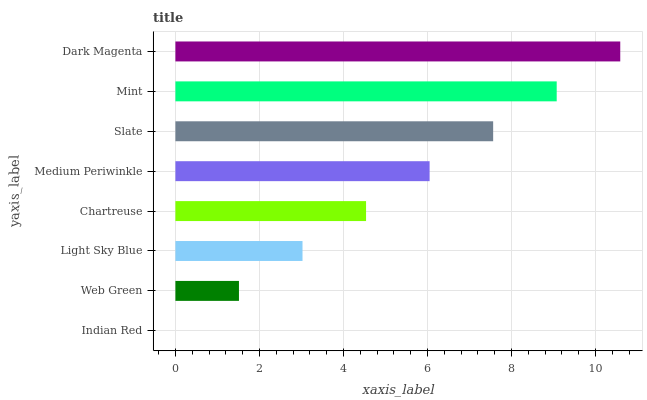Is Indian Red the minimum?
Answer yes or no. Yes. Is Dark Magenta the maximum?
Answer yes or no. Yes. Is Web Green the minimum?
Answer yes or no. No. Is Web Green the maximum?
Answer yes or no. No. Is Web Green greater than Indian Red?
Answer yes or no. Yes. Is Indian Red less than Web Green?
Answer yes or no. Yes. Is Indian Red greater than Web Green?
Answer yes or no. No. Is Web Green less than Indian Red?
Answer yes or no. No. Is Medium Periwinkle the high median?
Answer yes or no. Yes. Is Chartreuse the low median?
Answer yes or no. Yes. Is Chartreuse the high median?
Answer yes or no. No. Is Mint the low median?
Answer yes or no. No. 